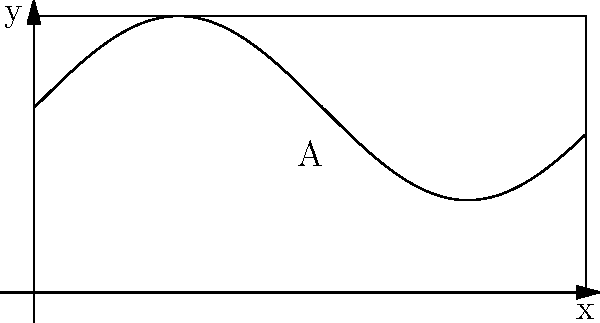As a responsible guardian, you want to estimate the area of an irregularly shaped playground for your nieces. The playground's boundary is represented by the function $y = 2 + \sin(x)$ from $x = 0$ to $x = 6$. Calculate the area of the playground using integration. To find the area under the curve $y = 2 + \sin(x)$ from $x = 0$ to $x = 6$, we need to integrate the function over this interval.

Step 1: Set up the integral
$$A = \int_0^6 (2 + \sin(x)) dx$$

Step 2: Integrate the function
$$A = [2x - \cos(x)]_0^6$$

Step 3: Evaluate the integral at the limits
$$A = (12 - \cos(6)) - (0 - \cos(0))$$
$$A = 12 - \cos(6) + 1$$

Step 4: Simplify
$$A = 13 - \cos(6)$$

Step 5: Calculate the final value (using a calculator)
$$A \approx 13.96 \text{ square units}$$

This result represents the estimated area of the irregularly shaped playground, which you can use to plan activities or safety measures for your nieces.
Answer: $13 - \cos(6) \approx 13.96 \text{ square units}$ 